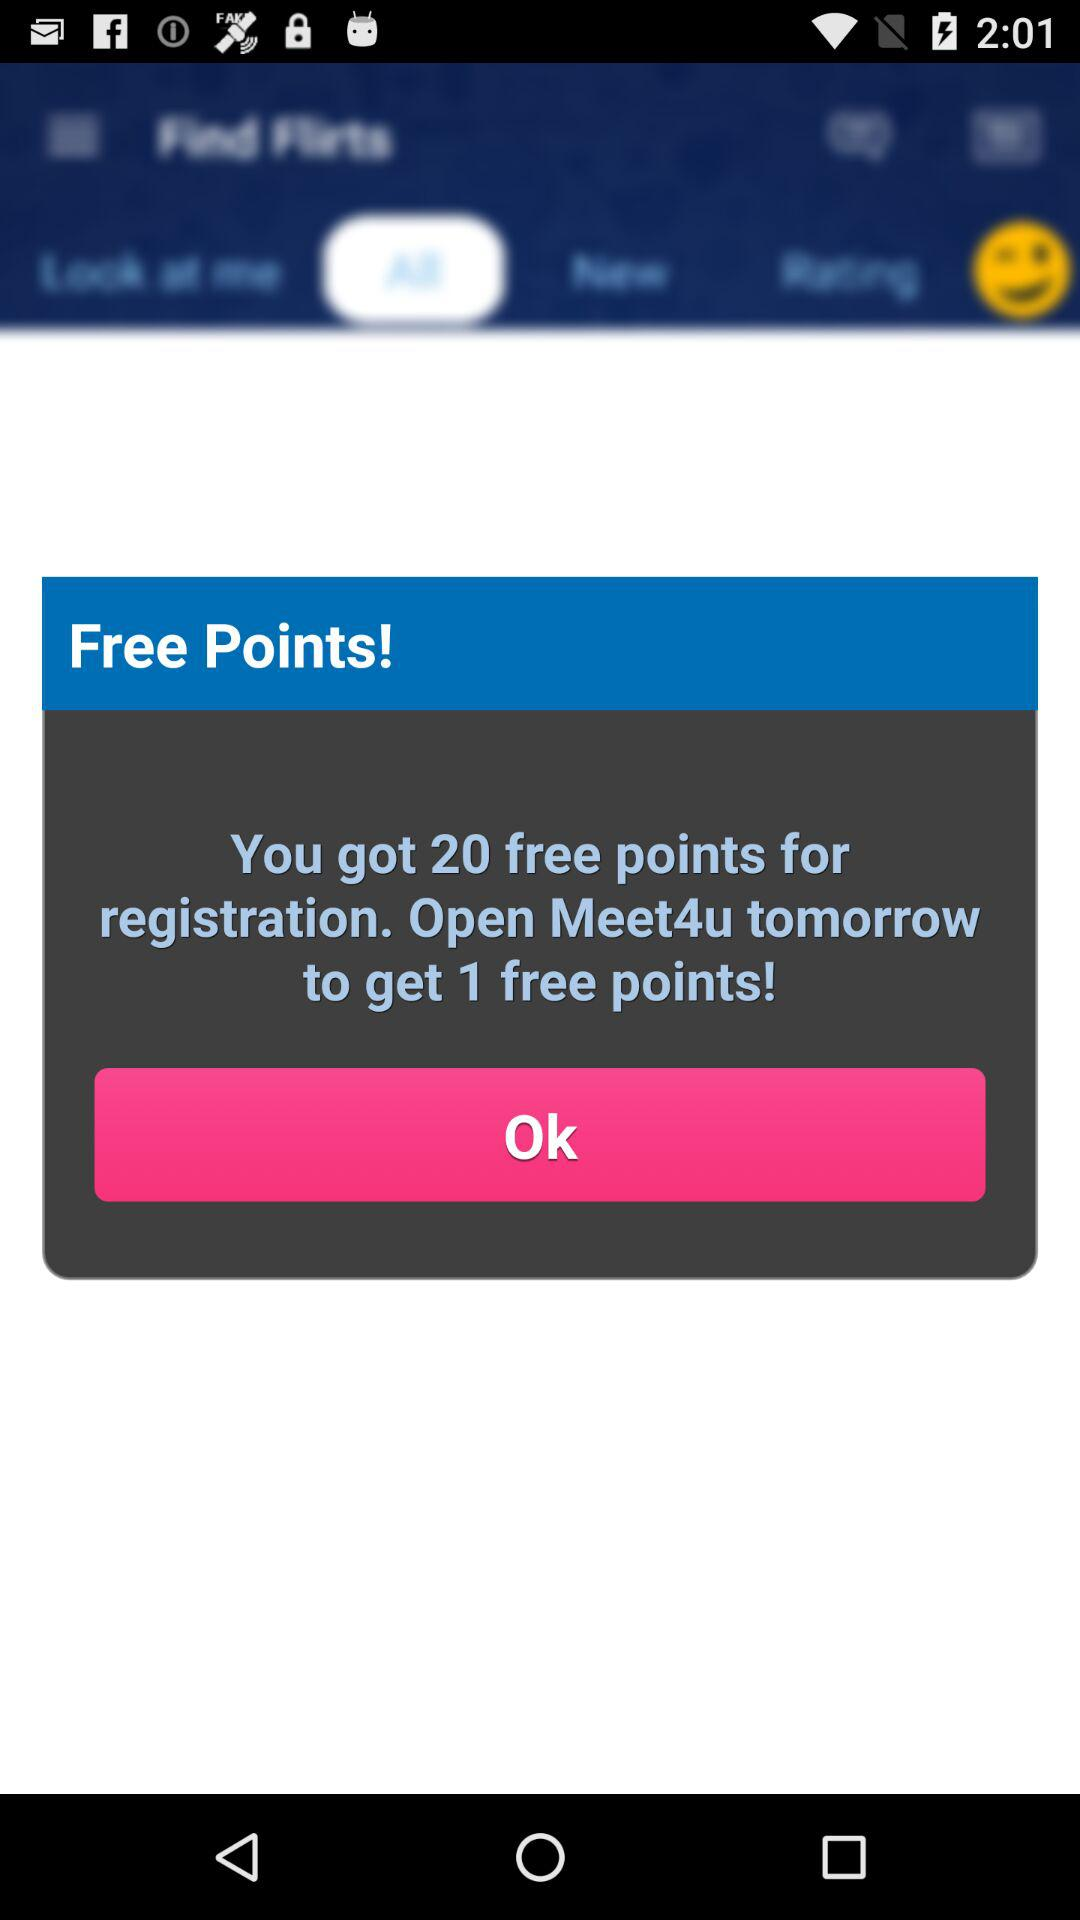What is the user's name?
When the provided information is insufficient, respond with <no answer>. <no answer> 